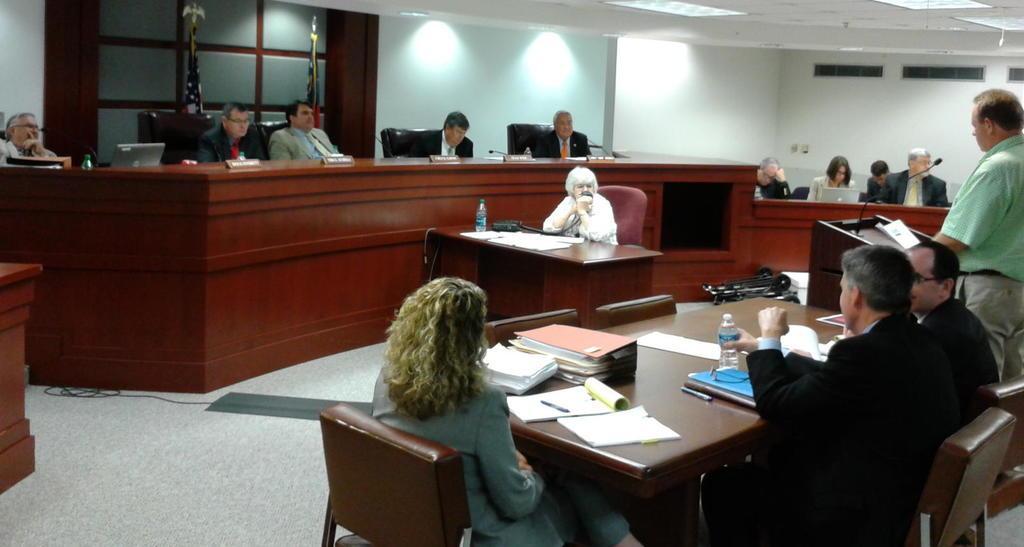Can you describe this image briefly? Here we can see a group of people who are sitting on a chair. There is a person on the top right. He is delivering a speech and there are a few people who are paying attention to his speech. 